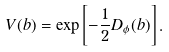<formula> <loc_0><loc_0><loc_500><loc_500>V ( b ) = \exp \left [ - \frac { 1 } { 2 } D _ { \phi } ( b ) \right ] .</formula> 